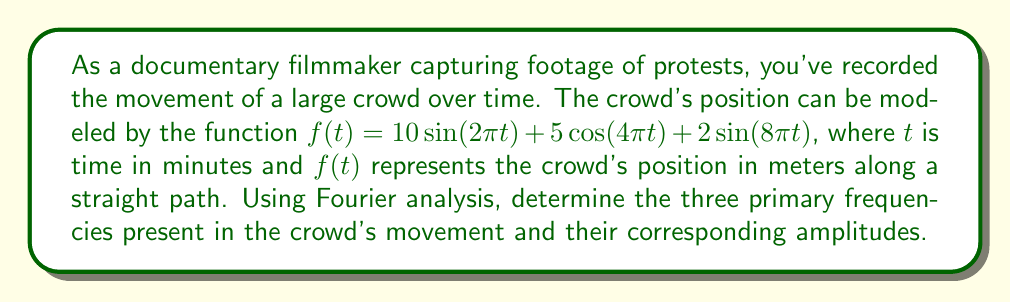Help me with this question. To solve this problem, we need to analyze the given function using Fourier analysis. The function is already expressed as a sum of sinusoidal components, which makes our task easier.

1. Identify the general form of a Fourier series:
   $$f(t) = \sum_{n=1}^{\infty} (a_n \sin(2\pi n f_0 t) + b_n \cos(2\pi n f_0 t))$$
   where $f_0$ is the fundamental frequency, and $a_n$ and $b_n$ are the amplitudes.

2. Compare our given function to this general form:
   $$f(t) = 10\sin(2\pi t) + 5\cos(4\pi t) + 2\sin(8\pi t)$$

3. Identify the components:
   - $10\sin(2\pi t)$: frequency = 1 Hz, amplitude = 10 m
   - $5\cos(4\pi t)$: frequency = 2 Hz, amplitude = 5 m
   - $2\sin(8\pi t)$: frequency = 4 Hz, amplitude = 2 m

4. Convert all terms to sine form for consistency:
   - $\cos(4\pi t) = \sin(4\pi t + \frac{\pi}{2})$
   So, $5\cos(4\pi t) = 5\sin(4\pi t + \frac{\pi}{2})$

5. Final representation:
   $$f(t) = 10\sin(2\pi t) + 5\sin(4\pi t + \frac{\pi}{2}) + 2\sin(8\pi t)$$

The three primary frequencies and their corresponding amplitudes are:
1. 1 Hz with amplitude 10 m
2. 2 Hz with amplitude 5 m
3. 4 Hz with amplitude 2 m
Answer: The three primary frequencies and their corresponding amplitudes are:
1. 1 Hz, 10 m
2. 2 Hz, 5 m
3. 4 Hz, 2 m 